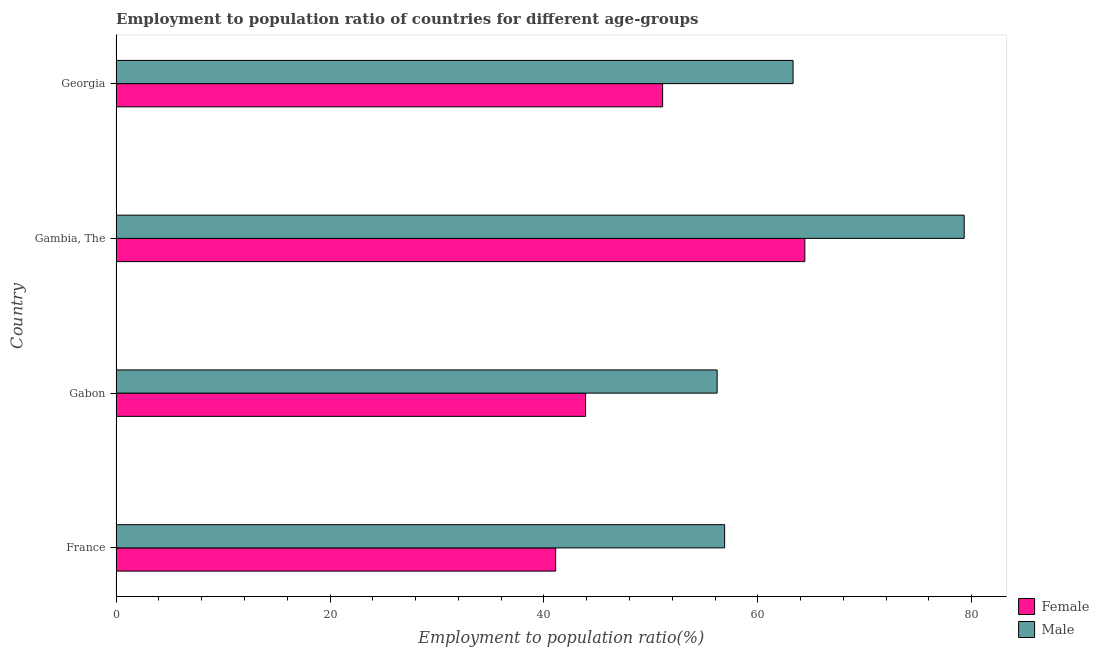How many different coloured bars are there?
Keep it short and to the point. 2. Are the number of bars per tick equal to the number of legend labels?
Your response must be concise. Yes. Are the number of bars on each tick of the Y-axis equal?
Your response must be concise. Yes. How many bars are there on the 1st tick from the top?
Provide a short and direct response. 2. How many bars are there on the 3rd tick from the bottom?
Provide a short and direct response. 2. What is the label of the 2nd group of bars from the top?
Your answer should be very brief. Gambia, The. What is the employment to population ratio(male) in Gambia, The?
Offer a terse response. 79.3. Across all countries, what is the maximum employment to population ratio(male)?
Provide a succinct answer. 79.3. Across all countries, what is the minimum employment to population ratio(male)?
Keep it short and to the point. 56.2. In which country was the employment to population ratio(female) maximum?
Your answer should be very brief. Gambia, The. In which country was the employment to population ratio(male) minimum?
Make the answer very short. Gabon. What is the total employment to population ratio(female) in the graph?
Ensure brevity in your answer.  200.5. What is the difference between the employment to population ratio(female) in Gambia, The and the employment to population ratio(male) in Georgia?
Ensure brevity in your answer.  1.1. What is the average employment to population ratio(female) per country?
Provide a succinct answer. 50.12. What is the difference between the employment to population ratio(female) and employment to population ratio(male) in Gabon?
Provide a short and direct response. -12.3. In how many countries, is the employment to population ratio(male) greater than 44 %?
Offer a terse response. 4. What is the ratio of the employment to population ratio(female) in France to that in Gabon?
Your response must be concise. 0.94. What is the difference between the highest and the lowest employment to population ratio(male)?
Your response must be concise. 23.1. Is the sum of the employment to population ratio(female) in France and Gabon greater than the maximum employment to population ratio(male) across all countries?
Your response must be concise. Yes. What does the 1st bar from the top in Gambia, The represents?
Make the answer very short. Male. What does the 2nd bar from the bottom in Gambia, The represents?
Offer a very short reply. Male. What is the difference between two consecutive major ticks on the X-axis?
Your answer should be very brief. 20. Are the values on the major ticks of X-axis written in scientific E-notation?
Make the answer very short. No. Does the graph contain any zero values?
Provide a succinct answer. No. What is the title of the graph?
Ensure brevity in your answer.  Employment to population ratio of countries for different age-groups. What is the Employment to population ratio(%) in Female in France?
Your answer should be very brief. 41.1. What is the Employment to population ratio(%) of Male in France?
Provide a succinct answer. 56.9. What is the Employment to population ratio(%) of Female in Gabon?
Your response must be concise. 43.9. What is the Employment to population ratio(%) in Male in Gabon?
Offer a terse response. 56.2. What is the Employment to population ratio(%) of Female in Gambia, The?
Make the answer very short. 64.4. What is the Employment to population ratio(%) in Male in Gambia, The?
Make the answer very short. 79.3. What is the Employment to population ratio(%) of Female in Georgia?
Offer a very short reply. 51.1. What is the Employment to population ratio(%) in Male in Georgia?
Ensure brevity in your answer.  63.3. Across all countries, what is the maximum Employment to population ratio(%) of Female?
Give a very brief answer. 64.4. Across all countries, what is the maximum Employment to population ratio(%) in Male?
Your answer should be compact. 79.3. Across all countries, what is the minimum Employment to population ratio(%) in Female?
Your answer should be very brief. 41.1. Across all countries, what is the minimum Employment to population ratio(%) of Male?
Keep it short and to the point. 56.2. What is the total Employment to population ratio(%) of Female in the graph?
Offer a very short reply. 200.5. What is the total Employment to population ratio(%) of Male in the graph?
Provide a short and direct response. 255.7. What is the difference between the Employment to population ratio(%) in Female in France and that in Gabon?
Make the answer very short. -2.8. What is the difference between the Employment to population ratio(%) in Male in France and that in Gabon?
Keep it short and to the point. 0.7. What is the difference between the Employment to population ratio(%) of Female in France and that in Gambia, The?
Your answer should be compact. -23.3. What is the difference between the Employment to population ratio(%) of Male in France and that in Gambia, The?
Provide a short and direct response. -22.4. What is the difference between the Employment to population ratio(%) of Female in France and that in Georgia?
Offer a very short reply. -10. What is the difference between the Employment to population ratio(%) in Male in France and that in Georgia?
Ensure brevity in your answer.  -6.4. What is the difference between the Employment to population ratio(%) in Female in Gabon and that in Gambia, The?
Make the answer very short. -20.5. What is the difference between the Employment to population ratio(%) of Male in Gabon and that in Gambia, The?
Offer a terse response. -23.1. What is the difference between the Employment to population ratio(%) of Male in Gambia, The and that in Georgia?
Provide a short and direct response. 16. What is the difference between the Employment to population ratio(%) of Female in France and the Employment to population ratio(%) of Male in Gabon?
Make the answer very short. -15.1. What is the difference between the Employment to population ratio(%) in Female in France and the Employment to population ratio(%) in Male in Gambia, The?
Keep it short and to the point. -38.2. What is the difference between the Employment to population ratio(%) in Female in France and the Employment to population ratio(%) in Male in Georgia?
Ensure brevity in your answer.  -22.2. What is the difference between the Employment to population ratio(%) of Female in Gabon and the Employment to population ratio(%) of Male in Gambia, The?
Offer a very short reply. -35.4. What is the difference between the Employment to population ratio(%) in Female in Gabon and the Employment to population ratio(%) in Male in Georgia?
Your answer should be very brief. -19.4. What is the difference between the Employment to population ratio(%) of Female in Gambia, The and the Employment to population ratio(%) of Male in Georgia?
Your answer should be compact. 1.1. What is the average Employment to population ratio(%) of Female per country?
Keep it short and to the point. 50.12. What is the average Employment to population ratio(%) of Male per country?
Provide a succinct answer. 63.92. What is the difference between the Employment to population ratio(%) in Female and Employment to population ratio(%) in Male in France?
Your response must be concise. -15.8. What is the difference between the Employment to population ratio(%) of Female and Employment to population ratio(%) of Male in Gambia, The?
Ensure brevity in your answer.  -14.9. What is the ratio of the Employment to population ratio(%) of Female in France to that in Gabon?
Ensure brevity in your answer.  0.94. What is the ratio of the Employment to population ratio(%) of Male in France to that in Gabon?
Your response must be concise. 1.01. What is the ratio of the Employment to population ratio(%) in Female in France to that in Gambia, The?
Give a very brief answer. 0.64. What is the ratio of the Employment to population ratio(%) in Male in France to that in Gambia, The?
Your response must be concise. 0.72. What is the ratio of the Employment to population ratio(%) in Female in France to that in Georgia?
Make the answer very short. 0.8. What is the ratio of the Employment to population ratio(%) in Male in France to that in Georgia?
Offer a very short reply. 0.9. What is the ratio of the Employment to population ratio(%) of Female in Gabon to that in Gambia, The?
Make the answer very short. 0.68. What is the ratio of the Employment to population ratio(%) in Male in Gabon to that in Gambia, The?
Your answer should be compact. 0.71. What is the ratio of the Employment to population ratio(%) in Female in Gabon to that in Georgia?
Give a very brief answer. 0.86. What is the ratio of the Employment to population ratio(%) of Male in Gabon to that in Georgia?
Provide a succinct answer. 0.89. What is the ratio of the Employment to population ratio(%) in Female in Gambia, The to that in Georgia?
Ensure brevity in your answer.  1.26. What is the ratio of the Employment to population ratio(%) in Male in Gambia, The to that in Georgia?
Your response must be concise. 1.25. What is the difference between the highest and the second highest Employment to population ratio(%) of Female?
Provide a succinct answer. 13.3. What is the difference between the highest and the lowest Employment to population ratio(%) of Female?
Give a very brief answer. 23.3. What is the difference between the highest and the lowest Employment to population ratio(%) of Male?
Your answer should be compact. 23.1. 